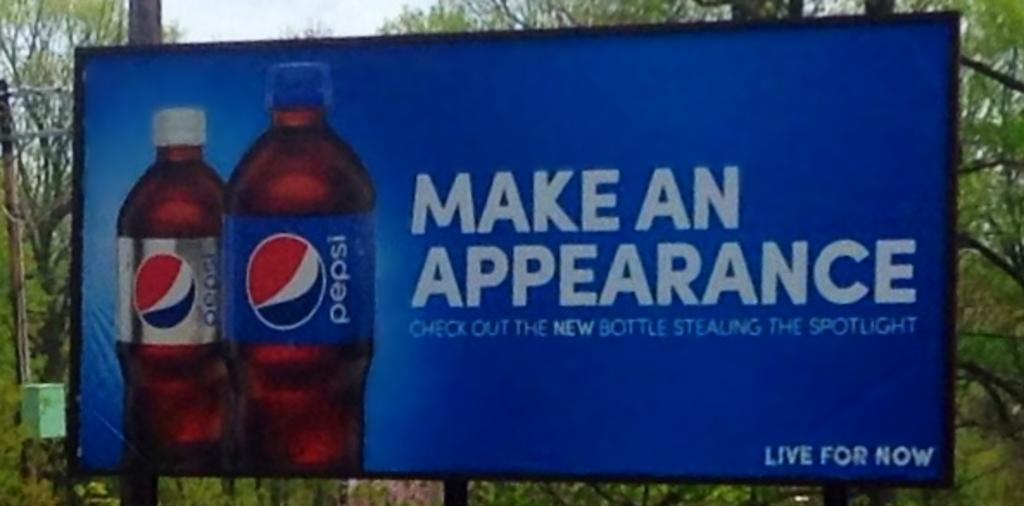What is the slogan for pepsi?
Ensure brevity in your answer.  Make an appearance. What does it want you to do?
Your answer should be very brief. Make an appearance. 